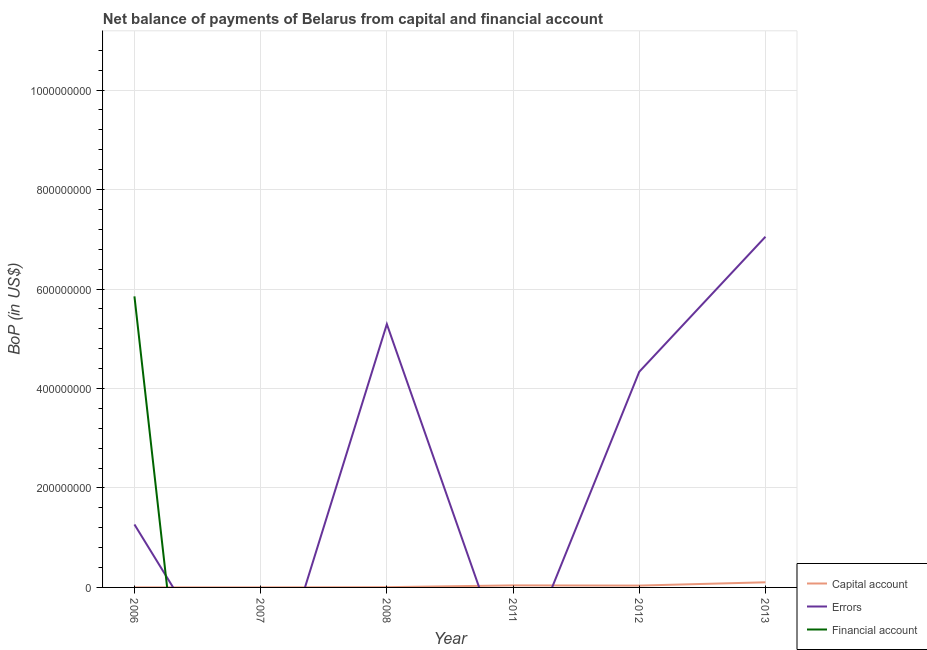How many different coloured lines are there?
Offer a very short reply. 3. Does the line corresponding to amount of errors intersect with the line corresponding to amount of net capital account?
Your response must be concise. Yes. Is the number of lines equal to the number of legend labels?
Your answer should be very brief. No. What is the amount of net capital account in 2006?
Keep it short and to the point. 1.00e+05. Across all years, what is the maximum amount of net capital account?
Make the answer very short. 1.03e+07. In which year was the amount of net capital account maximum?
Give a very brief answer. 2013. What is the total amount of net capital account in the graph?
Your answer should be compact. 1.88e+07. What is the difference between the amount of net capital account in 2008 and that in 2011?
Make the answer very short. -3.60e+06. What is the difference between the amount of errors in 2013 and the amount of financial account in 2006?
Your answer should be very brief. 1.20e+08. What is the average amount of net capital account per year?
Your response must be concise. 3.13e+06. In the year 2006, what is the difference between the amount of errors and amount of net capital account?
Give a very brief answer. 1.26e+08. In how many years, is the amount of errors greater than 600000000 US$?
Provide a succinct answer. 1. What is the ratio of the amount of net capital account in 2012 to that in 2013?
Provide a short and direct response. 0.36. Is the amount of net capital account in 2012 less than that in 2013?
Ensure brevity in your answer.  Yes. Is the difference between the amount of net capital account in 2006 and 2008 greater than the difference between the amount of errors in 2006 and 2008?
Your answer should be compact. Yes. What is the difference between the highest and the second highest amount of errors?
Ensure brevity in your answer.  1.76e+08. What is the difference between the highest and the lowest amount of financial account?
Make the answer very short. 5.85e+08. Is the amount of financial account strictly less than the amount of errors over the years?
Offer a terse response. No. What is the difference between two consecutive major ticks on the Y-axis?
Provide a short and direct response. 2.00e+08. Are the values on the major ticks of Y-axis written in scientific E-notation?
Provide a succinct answer. No. Does the graph contain grids?
Your answer should be very brief. Yes. How are the legend labels stacked?
Make the answer very short. Vertical. What is the title of the graph?
Your answer should be very brief. Net balance of payments of Belarus from capital and financial account. What is the label or title of the Y-axis?
Offer a very short reply. BoP (in US$). What is the BoP (in US$) of Capital account in 2006?
Ensure brevity in your answer.  1.00e+05. What is the BoP (in US$) of Errors in 2006?
Offer a terse response. 1.27e+08. What is the BoP (in US$) of Financial account in 2006?
Provide a succinct answer. 5.85e+08. What is the BoP (in US$) of Errors in 2007?
Your answer should be compact. 0. What is the BoP (in US$) of Financial account in 2007?
Make the answer very short. 0. What is the BoP (in US$) of Capital account in 2008?
Provide a succinct answer. 5.00e+05. What is the BoP (in US$) of Errors in 2008?
Your answer should be compact. 5.29e+08. What is the BoP (in US$) in Capital account in 2011?
Provide a short and direct response. 4.10e+06. What is the BoP (in US$) of Errors in 2011?
Your response must be concise. 0. What is the BoP (in US$) in Financial account in 2011?
Provide a short and direct response. 0. What is the BoP (in US$) of Capital account in 2012?
Offer a terse response. 3.70e+06. What is the BoP (in US$) of Errors in 2012?
Offer a terse response. 4.34e+08. What is the BoP (in US$) of Financial account in 2012?
Offer a very short reply. 0. What is the BoP (in US$) in Capital account in 2013?
Offer a terse response. 1.03e+07. What is the BoP (in US$) in Errors in 2013?
Make the answer very short. 7.05e+08. Across all years, what is the maximum BoP (in US$) of Capital account?
Keep it short and to the point. 1.03e+07. Across all years, what is the maximum BoP (in US$) of Errors?
Provide a short and direct response. 7.05e+08. Across all years, what is the maximum BoP (in US$) of Financial account?
Provide a succinct answer. 5.85e+08. Across all years, what is the minimum BoP (in US$) of Capital account?
Provide a short and direct response. 1.00e+05. Across all years, what is the minimum BoP (in US$) of Errors?
Your answer should be very brief. 0. What is the total BoP (in US$) in Capital account in the graph?
Give a very brief answer. 1.88e+07. What is the total BoP (in US$) in Errors in the graph?
Your answer should be very brief. 1.79e+09. What is the total BoP (in US$) in Financial account in the graph?
Provide a short and direct response. 5.85e+08. What is the difference between the BoP (in US$) in Capital account in 2006 and that in 2008?
Your response must be concise. -4.00e+05. What is the difference between the BoP (in US$) of Errors in 2006 and that in 2008?
Your response must be concise. -4.03e+08. What is the difference between the BoP (in US$) of Capital account in 2006 and that in 2012?
Your answer should be compact. -3.60e+06. What is the difference between the BoP (in US$) of Errors in 2006 and that in 2012?
Make the answer very short. -3.07e+08. What is the difference between the BoP (in US$) of Capital account in 2006 and that in 2013?
Offer a terse response. -1.02e+07. What is the difference between the BoP (in US$) of Errors in 2006 and that in 2013?
Make the answer very short. -5.78e+08. What is the difference between the BoP (in US$) of Capital account in 2007 and that in 2008?
Keep it short and to the point. -4.00e+05. What is the difference between the BoP (in US$) of Capital account in 2007 and that in 2011?
Your answer should be compact. -4.00e+06. What is the difference between the BoP (in US$) of Capital account in 2007 and that in 2012?
Keep it short and to the point. -3.60e+06. What is the difference between the BoP (in US$) in Capital account in 2007 and that in 2013?
Your answer should be compact. -1.02e+07. What is the difference between the BoP (in US$) of Capital account in 2008 and that in 2011?
Provide a succinct answer. -3.60e+06. What is the difference between the BoP (in US$) in Capital account in 2008 and that in 2012?
Give a very brief answer. -3.20e+06. What is the difference between the BoP (in US$) in Errors in 2008 and that in 2012?
Provide a succinct answer. 9.58e+07. What is the difference between the BoP (in US$) in Capital account in 2008 and that in 2013?
Offer a terse response. -9.80e+06. What is the difference between the BoP (in US$) in Errors in 2008 and that in 2013?
Give a very brief answer. -1.76e+08. What is the difference between the BoP (in US$) of Capital account in 2011 and that in 2013?
Provide a short and direct response. -6.20e+06. What is the difference between the BoP (in US$) in Capital account in 2012 and that in 2013?
Make the answer very short. -6.60e+06. What is the difference between the BoP (in US$) in Errors in 2012 and that in 2013?
Give a very brief answer. -2.72e+08. What is the difference between the BoP (in US$) of Capital account in 2006 and the BoP (in US$) of Errors in 2008?
Ensure brevity in your answer.  -5.29e+08. What is the difference between the BoP (in US$) of Capital account in 2006 and the BoP (in US$) of Errors in 2012?
Make the answer very short. -4.34e+08. What is the difference between the BoP (in US$) of Capital account in 2006 and the BoP (in US$) of Errors in 2013?
Your answer should be very brief. -7.05e+08. What is the difference between the BoP (in US$) in Capital account in 2007 and the BoP (in US$) in Errors in 2008?
Give a very brief answer. -5.29e+08. What is the difference between the BoP (in US$) of Capital account in 2007 and the BoP (in US$) of Errors in 2012?
Your answer should be compact. -4.34e+08. What is the difference between the BoP (in US$) of Capital account in 2007 and the BoP (in US$) of Errors in 2013?
Your response must be concise. -7.05e+08. What is the difference between the BoP (in US$) of Capital account in 2008 and the BoP (in US$) of Errors in 2012?
Your answer should be very brief. -4.33e+08. What is the difference between the BoP (in US$) of Capital account in 2008 and the BoP (in US$) of Errors in 2013?
Your answer should be very brief. -7.05e+08. What is the difference between the BoP (in US$) in Capital account in 2011 and the BoP (in US$) in Errors in 2012?
Offer a very short reply. -4.30e+08. What is the difference between the BoP (in US$) of Capital account in 2011 and the BoP (in US$) of Errors in 2013?
Ensure brevity in your answer.  -7.01e+08. What is the difference between the BoP (in US$) in Capital account in 2012 and the BoP (in US$) in Errors in 2013?
Make the answer very short. -7.01e+08. What is the average BoP (in US$) of Capital account per year?
Ensure brevity in your answer.  3.13e+06. What is the average BoP (in US$) of Errors per year?
Ensure brevity in your answer.  2.99e+08. What is the average BoP (in US$) of Financial account per year?
Offer a terse response. 9.75e+07. In the year 2006, what is the difference between the BoP (in US$) of Capital account and BoP (in US$) of Errors?
Offer a very short reply. -1.26e+08. In the year 2006, what is the difference between the BoP (in US$) of Capital account and BoP (in US$) of Financial account?
Provide a short and direct response. -5.85e+08. In the year 2006, what is the difference between the BoP (in US$) in Errors and BoP (in US$) in Financial account?
Provide a short and direct response. -4.59e+08. In the year 2008, what is the difference between the BoP (in US$) in Capital account and BoP (in US$) in Errors?
Ensure brevity in your answer.  -5.29e+08. In the year 2012, what is the difference between the BoP (in US$) in Capital account and BoP (in US$) in Errors?
Your answer should be very brief. -4.30e+08. In the year 2013, what is the difference between the BoP (in US$) of Capital account and BoP (in US$) of Errors?
Your answer should be very brief. -6.95e+08. What is the ratio of the BoP (in US$) in Capital account in 2006 to that in 2007?
Your answer should be very brief. 1. What is the ratio of the BoP (in US$) in Capital account in 2006 to that in 2008?
Your answer should be very brief. 0.2. What is the ratio of the BoP (in US$) of Errors in 2006 to that in 2008?
Ensure brevity in your answer.  0.24. What is the ratio of the BoP (in US$) of Capital account in 2006 to that in 2011?
Your answer should be very brief. 0.02. What is the ratio of the BoP (in US$) in Capital account in 2006 to that in 2012?
Offer a terse response. 0.03. What is the ratio of the BoP (in US$) of Errors in 2006 to that in 2012?
Give a very brief answer. 0.29. What is the ratio of the BoP (in US$) of Capital account in 2006 to that in 2013?
Ensure brevity in your answer.  0.01. What is the ratio of the BoP (in US$) in Errors in 2006 to that in 2013?
Offer a very short reply. 0.18. What is the ratio of the BoP (in US$) in Capital account in 2007 to that in 2011?
Keep it short and to the point. 0.02. What is the ratio of the BoP (in US$) in Capital account in 2007 to that in 2012?
Provide a succinct answer. 0.03. What is the ratio of the BoP (in US$) of Capital account in 2007 to that in 2013?
Keep it short and to the point. 0.01. What is the ratio of the BoP (in US$) of Capital account in 2008 to that in 2011?
Offer a very short reply. 0.12. What is the ratio of the BoP (in US$) in Capital account in 2008 to that in 2012?
Offer a terse response. 0.14. What is the ratio of the BoP (in US$) of Errors in 2008 to that in 2012?
Make the answer very short. 1.22. What is the ratio of the BoP (in US$) of Capital account in 2008 to that in 2013?
Your answer should be very brief. 0.05. What is the ratio of the BoP (in US$) of Errors in 2008 to that in 2013?
Provide a succinct answer. 0.75. What is the ratio of the BoP (in US$) of Capital account in 2011 to that in 2012?
Make the answer very short. 1.11. What is the ratio of the BoP (in US$) in Capital account in 2011 to that in 2013?
Offer a very short reply. 0.4. What is the ratio of the BoP (in US$) of Capital account in 2012 to that in 2013?
Keep it short and to the point. 0.36. What is the ratio of the BoP (in US$) in Errors in 2012 to that in 2013?
Offer a terse response. 0.61. What is the difference between the highest and the second highest BoP (in US$) of Capital account?
Provide a succinct answer. 6.20e+06. What is the difference between the highest and the second highest BoP (in US$) of Errors?
Ensure brevity in your answer.  1.76e+08. What is the difference between the highest and the lowest BoP (in US$) in Capital account?
Your answer should be compact. 1.02e+07. What is the difference between the highest and the lowest BoP (in US$) in Errors?
Provide a short and direct response. 7.05e+08. What is the difference between the highest and the lowest BoP (in US$) in Financial account?
Keep it short and to the point. 5.85e+08. 